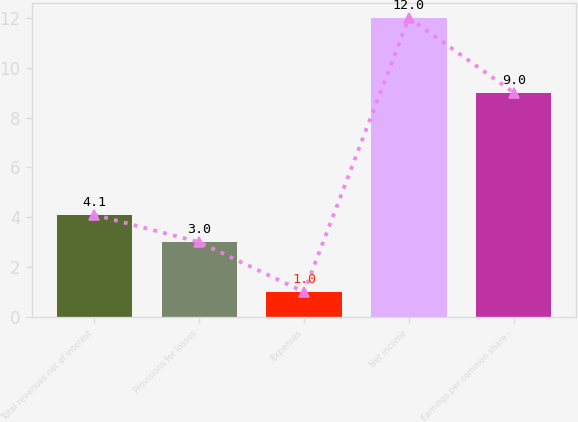Convert chart. <chart><loc_0><loc_0><loc_500><loc_500><bar_chart><fcel>Total revenues net of interest<fcel>Provisions for losses<fcel>Expenses<fcel>Net income<fcel>Earnings per common share -<nl><fcel>4.1<fcel>3<fcel>1<fcel>12<fcel>9<nl></chart> 